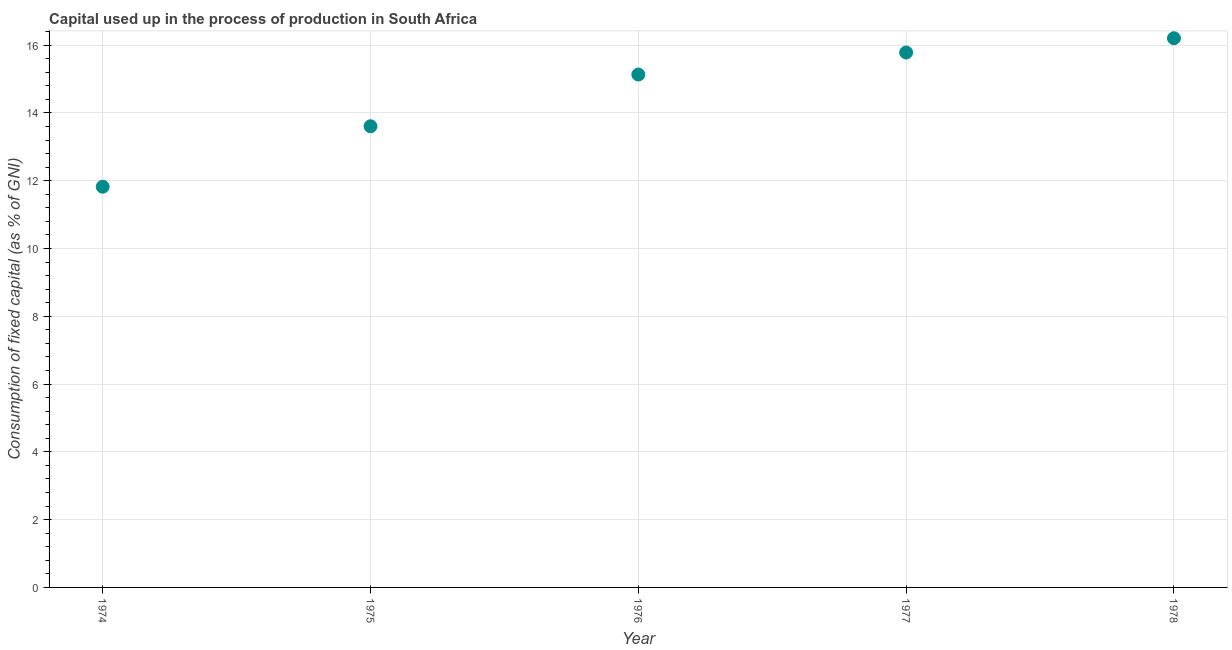What is the consumption of fixed capital in 1978?
Your answer should be very brief. 16.2. Across all years, what is the maximum consumption of fixed capital?
Provide a succinct answer. 16.2. Across all years, what is the minimum consumption of fixed capital?
Your answer should be very brief. 11.82. In which year was the consumption of fixed capital maximum?
Give a very brief answer. 1978. In which year was the consumption of fixed capital minimum?
Your answer should be very brief. 1974. What is the sum of the consumption of fixed capital?
Give a very brief answer. 72.55. What is the difference between the consumption of fixed capital in 1974 and 1975?
Offer a terse response. -1.78. What is the average consumption of fixed capital per year?
Keep it short and to the point. 14.51. What is the median consumption of fixed capital?
Provide a succinct answer. 15.13. What is the ratio of the consumption of fixed capital in 1974 to that in 1976?
Your response must be concise. 0.78. Is the difference between the consumption of fixed capital in 1974 and 1978 greater than the difference between any two years?
Keep it short and to the point. Yes. What is the difference between the highest and the second highest consumption of fixed capital?
Offer a very short reply. 0.42. Is the sum of the consumption of fixed capital in 1974 and 1978 greater than the maximum consumption of fixed capital across all years?
Your answer should be compact. Yes. What is the difference between the highest and the lowest consumption of fixed capital?
Ensure brevity in your answer.  4.38. Does the consumption of fixed capital monotonically increase over the years?
Your answer should be very brief. Yes. How many dotlines are there?
Make the answer very short. 1. How many years are there in the graph?
Ensure brevity in your answer.  5. Are the values on the major ticks of Y-axis written in scientific E-notation?
Give a very brief answer. No. Does the graph contain grids?
Ensure brevity in your answer.  Yes. What is the title of the graph?
Provide a succinct answer. Capital used up in the process of production in South Africa. What is the label or title of the X-axis?
Make the answer very short. Year. What is the label or title of the Y-axis?
Your answer should be compact. Consumption of fixed capital (as % of GNI). What is the Consumption of fixed capital (as % of GNI) in 1974?
Your answer should be compact. 11.82. What is the Consumption of fixed capital (as % of GNI) in 1975?
Offer a terse response. 13.61. What is the Consumption of fixed capital (as % of GNI) in 1976?
Your response must be concise. 15.13. What is the Consumption of fixed capital (as % of GNI) in 1977?
Your response must be concise. 15.78. What is the Consumption of fixed capital (as % of GNI) in 1978?
Offer a very short reply. 16.2. What is the difference between the Consumption of fixed capital (as % of GNI) in 1974 and 1975?
Your answer should be very brief. -1.78. What is the difference between the Consumption of fixed capital (as % of GNI) in 1974 and 1976?
Keep it short and to the point. -3.31. What is the difference between the Consumption of fixed capital (as % of GNI) in 1974 and 1977?
Provide a succinct answer. -3.96. What is the difference between the Consumption of fixed capital (as % of GNI) in 1974 and 1978?
Your answer should be very brief. -4.38. What is the difference between the Consumption of fixed capital (as % of GNI) in 1975 and 1976?
Provide a succinct answer. -1.53. What is the difference between the Consumption of fixed capital (as % of GNI) in 1975 and 1977?
Your answer should be very brief. -2.18. What is the difference between the Consumption of fixed capital (as % of GNI) in 1975 and 1978?
Provide a short and direct response. -2.6. What is the difference between the Consumption of fixed capital (as % of GNI) in 1976 and 1977?
Keep it short and to the point. -0.65. What is the difference between the Consumption of fixed capital (as % of GNI) in 1976 and 1978?
Your answer should be compact. -1.07. What is the difference between the Consumption of fixed capital (as % of GNI) in 1977 and 1978?
Your answer should be compact. -0.42. What is the ratio of the Consumption of fixed capital (as % of GNI) in 1974 to that in 1975?
Ensure brevity in your answer.  0.87. What is the ratio of the Consumption of fixed capital (as % of GNI) in 1974 to that in 1976?
Offer a very short reply. 0.78. What is the ratio of the Consumption of fixed capital (as % of GNI) in 1974 to that in 1977?
Offer a terse response. 0.75. What is the ratio of the Consumption of fixed capital (as % of GNI) in 1974 to that in 1978?
Your response must be concise. 0.73. What is the ratio of the Consumption of fixed capital (as % of GNI) in 1975 to that in 1976?
Your answer should be compact. 0.9. What is the ratio of the Consumption of fixed capital (as % of GNI) in 1975 to that in 1977?
Provide a succinct answer. 0.86. What is the ratio of the Consumption of fixed capital (as % of GNI) in 1975 to that in 1978?
Your answer should be compact. 0.84. What is the ratio of the Consumption of fixed capital (as % of GNI) in 1976 to that in 1977?
Offer a terse response. 0.96. What is the ratio of the Consumption of fixed capital (as % of GNI) in 1976 to that in 1978?
Make the answer very short. 0.93. 